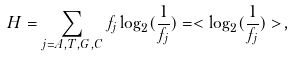Convert formula to latex. <formula><loc_0><loc_0><loc_500><loc_500>H = \sum _ { j = A , T , G , C } f _ { j } \log _ { 2 } ( \frac { 1 } { f _ { j } } ) = < { \log _ { 2 } ( \frac { 1 } { f _ { j } } ) } > ,</formula> 